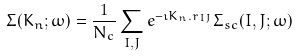<formula> <loc_0><loc_0><loc_500><loc_500>\Sigma ( { K } _ { n } ; \omega ) = \frac { 1 } { N _ { c } } \sum _ { I , J } e ^ { - \imath { K } _ { n } . { r } _ { I J } } \Sigma _ { s c } ( I , J ; \omega )</formula> 